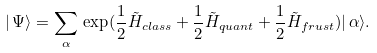<formula> <loc_0><loc_0><loc_500><loc_500>| \, \Psi \rangle = \sum _ { \alpha } \, \exp ( \frac { 1 } { 2 } \tilde { H } _ { c l a s s } + \frac { 1 } { 2 } \tilde { H } _ { q u a n t } + \frac { 1 } { 2 } \tilde { H } _ { f r u s t } ) | \, \alpha \rangle .</formula> 